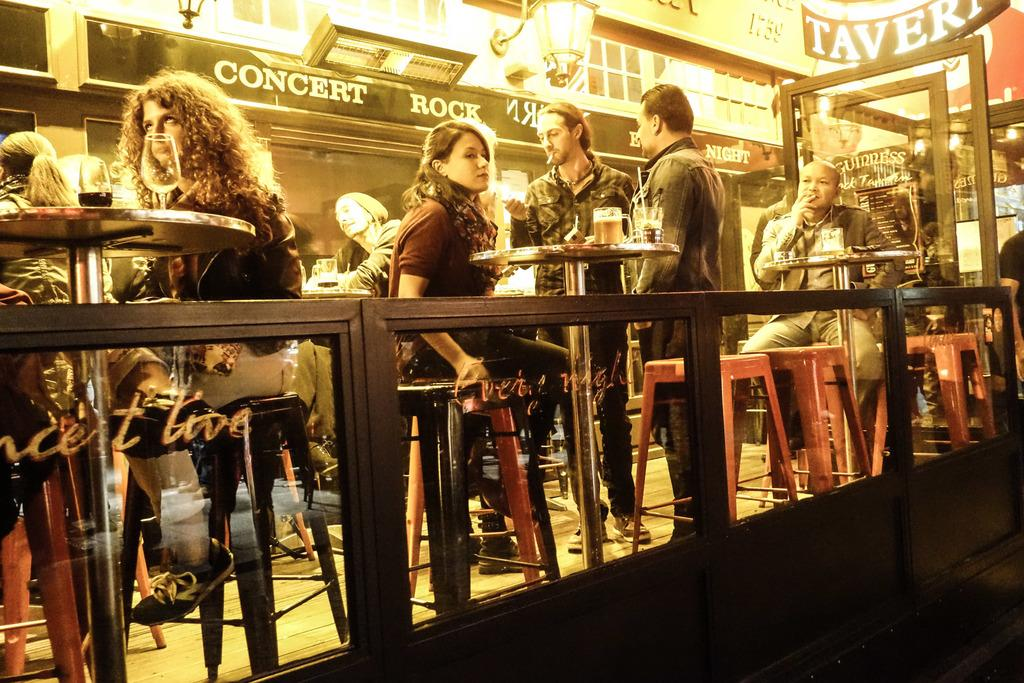What can be seen in the image involving multiple individuals? There are groups of people in the image. What are the people gathered around? There are tables in front of the people. What objects are placed on the tables? There are glasses on top of the tables. What is visible at the top of the image? There are lights visible at the top of the image. Are there any pets sitting on the sofa in the image? There is no sofa or pets present in the image. 